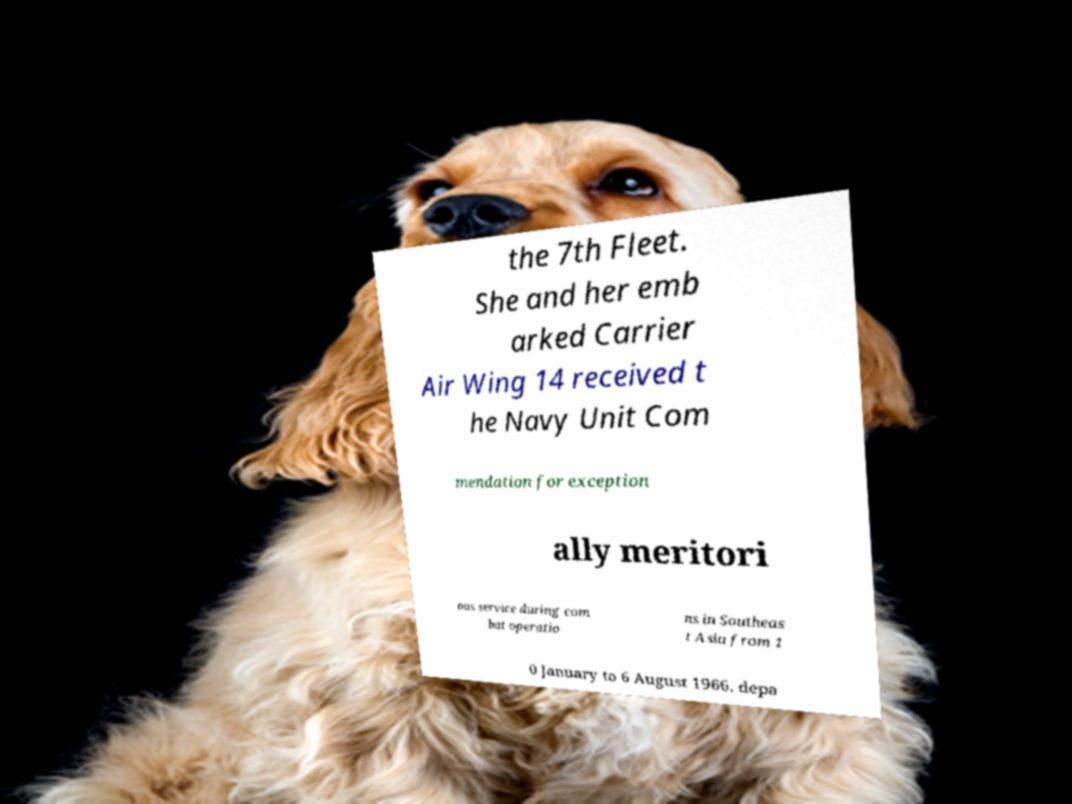What messages or text are displayed in this image? I need them in a readable, typed format. the 7th Fleet. She and her emb arked Carrier Air Wing 14 received t he Navy Unit Com mendation for exception ally meritori ous service during com bat operatio ns in Southeas t Asia from 1 0 January to 6 August 1966. depa 